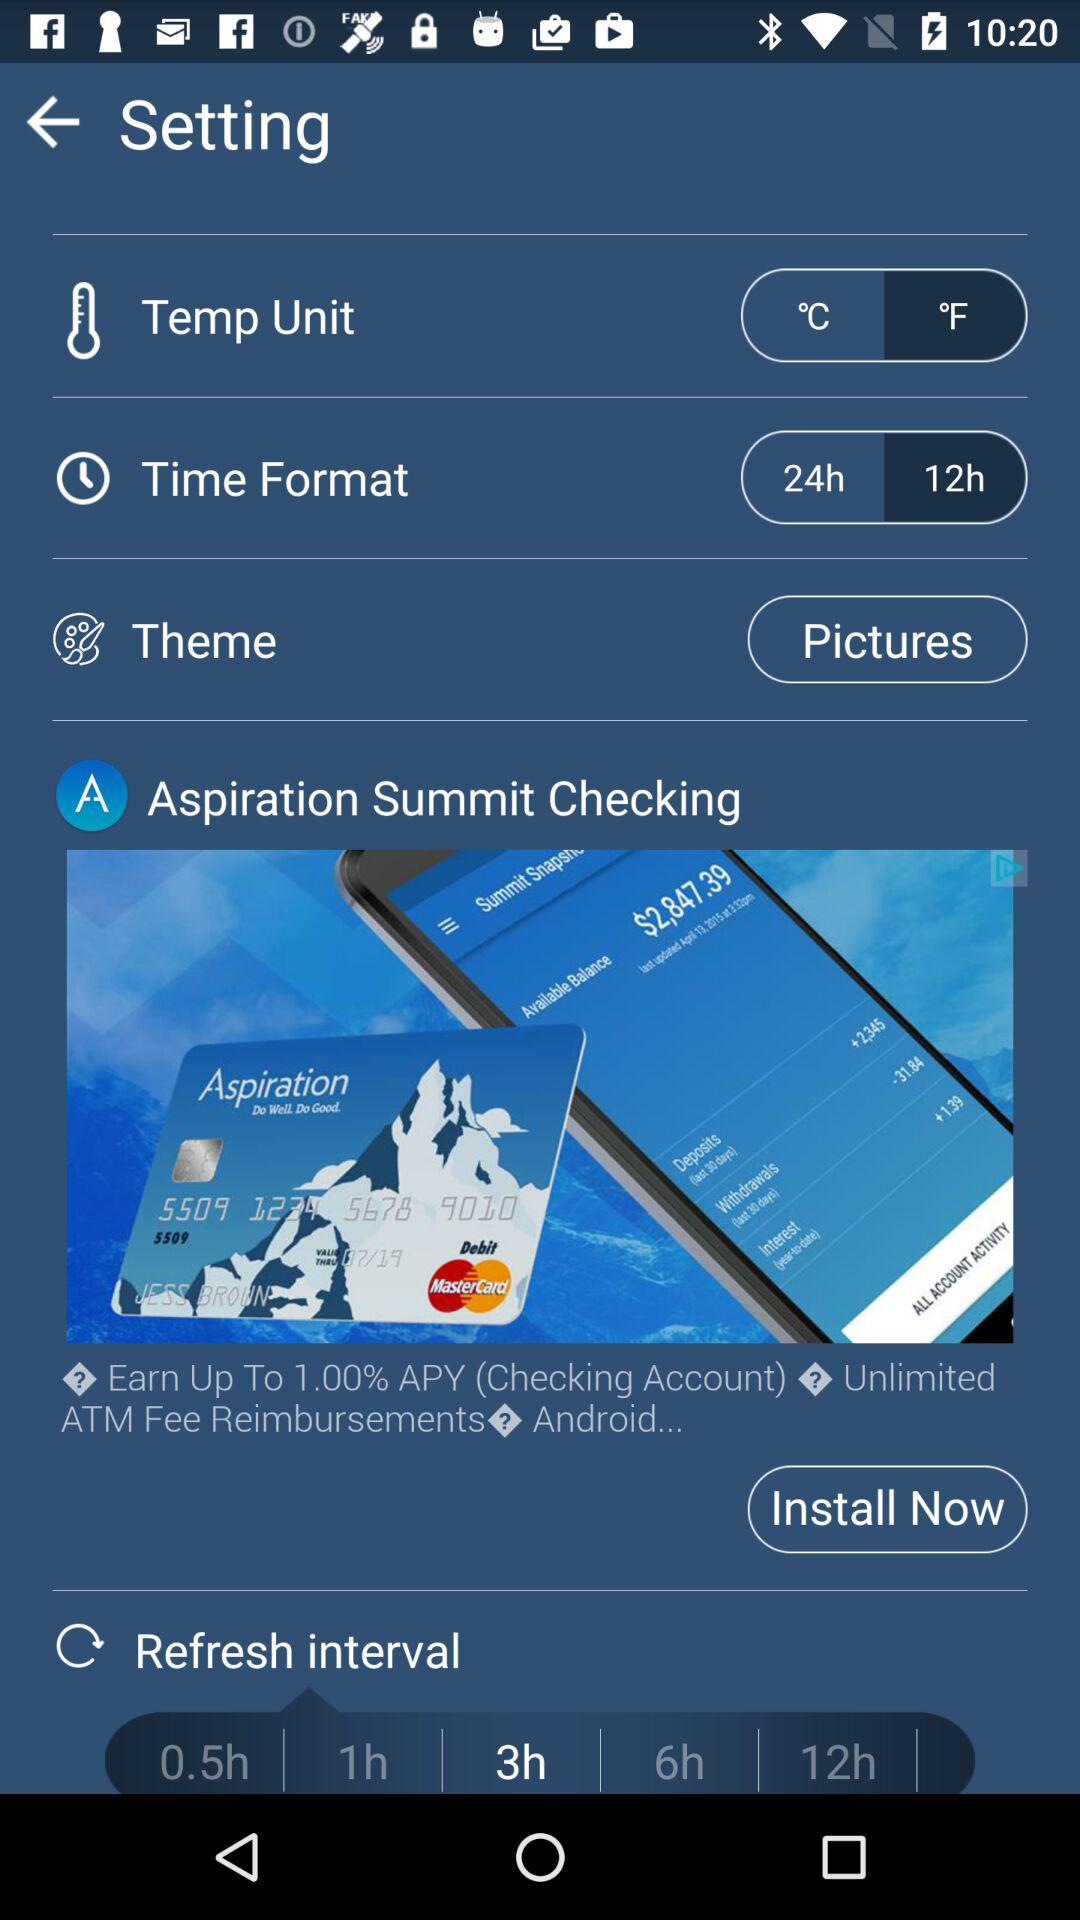Which option is selected for the refresh interval? The selected option for the refresh interval is 3 hours. 